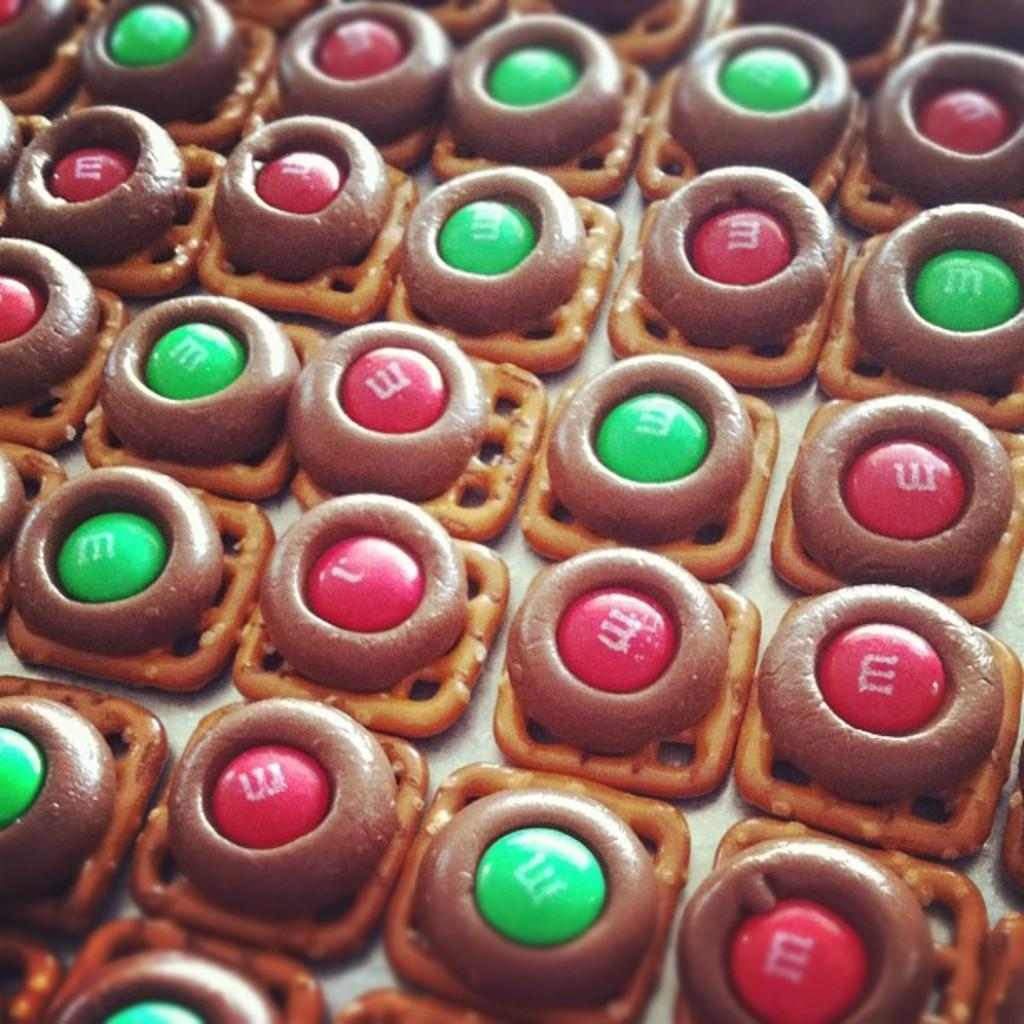What type of food can be seen in the image? The food looks like cookies. Can you describe the appearance of the cookies in the image? The cookies appear to be round and have a light-colored surface. Is the team of quicksand visible in the image? There is no team of quicksand or any quicksand present in the image. What type of blade is being used to cut the cookies in the image? There is no blade visible in the image, and the cookies do not appear to be cut. 